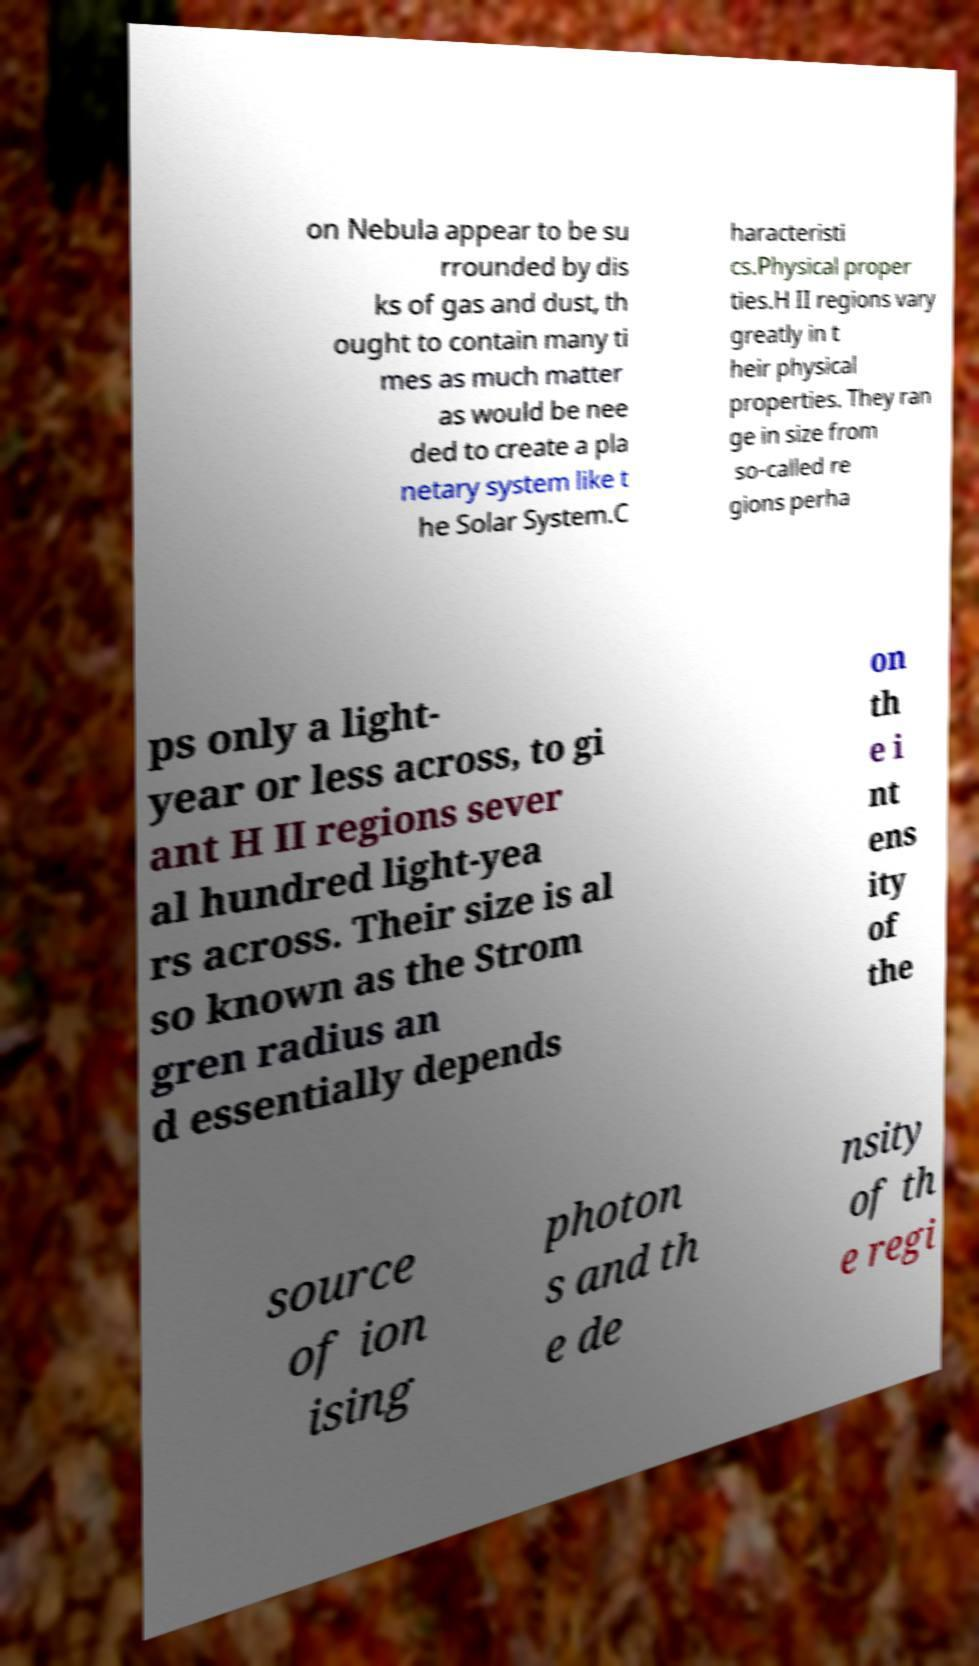Can you accurately transcribe the text from the provided image for me? on Nebula appear to be su rrounded by dis ks of gas and dust, th ought to contain many ti mes as much matter as would be nee ded to create a pla netary system like t he Solar System.C haracteristi cs.Physical proper ties.H II regions vary greatly in t heir physical properties. They ran ge in size from so-called re gions perha ps only a light- year or less across, to gi ant H II regions sever al hundred light-yea rs across. Their size is al so known as the Strom gren radius an d essentially depends on th e i nt ens ity of the source of ion ising photon s and th e de nsity of th e regi 